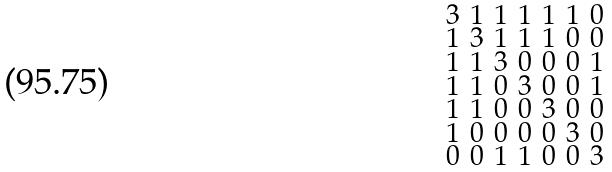<formula> <loc_0><loc_0><loc_500><loc_500>\begin{smallmatrix} 3 & 1 & 1 & 1 & 1 & 1 & 0 \\ 1 & 3 & 1 & 1 & 1 & 0 & 0 \\ 1 & 1 & 3 & 0 & 0 & 0 & 1 \\ 1 & 1 & 0 & 3 & 0 & 0 & 1 \\ 1 & 1 & 0 & 0 & 3 & 0 & 0 \\ 1 & 0 & 0 & 0 & 0 & 3 & 0 \\ 0 & 0 & 1 & 1 & 0 & 0 & 3 \end{smallmatrix}</formula> 